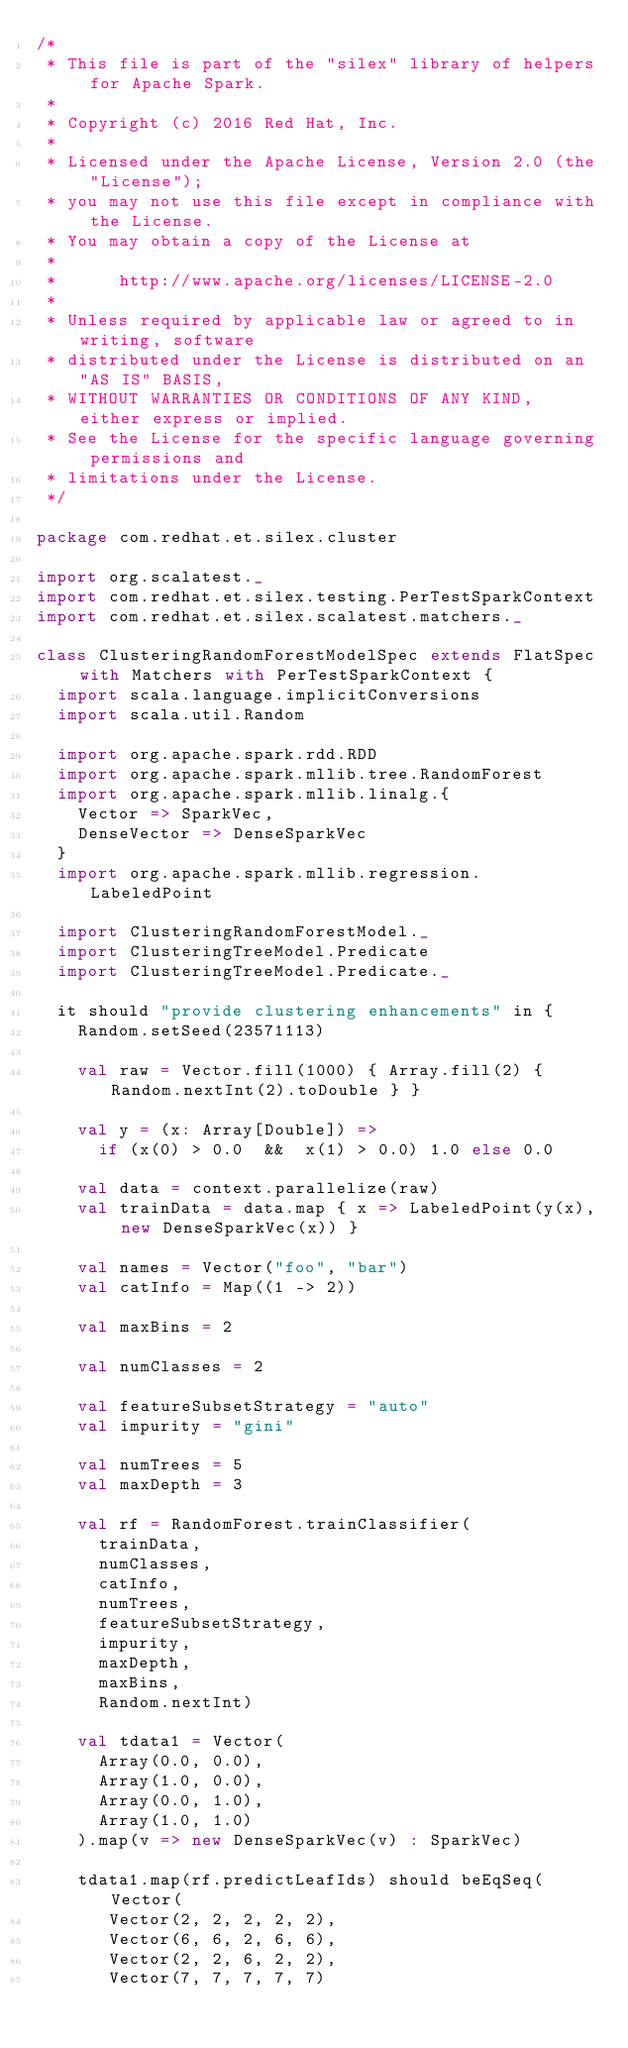Convert code to text. <code><loc_0><loc_0><loc_500><loc_500><_Scala_>/*
 * This file is part of the "silex" library of helpers for Apache Spark.
 *
 * Copyright (c) 2016 Red Hat, Inc.
 * 
 * Licensed under the Apache License, Version 2.0 (the "License");
 * you may not use this file except in compliance with the License.
 * You may obtain a copy of the License at
 * 
 *      http://www.apache.org/licenses/LICENSE-2.0
 * 
 * Unless required by applicable law or agreed to in writing, software
 * distributed under the License is distributed on an "AS IS" BASIS,
 * WITHOUT WARRANTIES OR CONDITIONS OF ANY KIND, either express or implied.
 * See the License for the specific language governing permissions and
 * limitations under the License.
 */

package com.redhat.et.silex.cluster

import org.scalatest._
import com.redhat.et.silex.testing.PerTestSparkContext
import com.redhat.et.silex.scalatest.matchers._

class ClusteringRandomForestModelSpec extends FlatSpec with Matchers with PerTestSparkContext {
  import scala.language.implicitConversions
  import scala.util.Random

  import org.apache.spark.rdd.RDD
  import org.apache.spark.mllib.tree.RandomForest
  import org.apache.spark.mllib.linalg.{
    Vector => SparkVec,
    DenseVector => DenseSparkVec
  }
  import org.apache.spark.mllib.regression.LabeledPoint

  import ClusteringRandomForestModel._
  import ClusteringTreeModel.Predicate
  import ClusteringTreeModel.Predicate._

  it should "provide clustering enhancements" in {
    Random.setSeed(23571113)

    val raw = Vector.fill(1000) { Array.fill(2) { Random.nextInt(2).toDouble } }

    val y = (x: Array[Double]) =>
      if (x(0) > 0.0  &&  x(1) > 0.0) 1.0 else 0.0

    val data = context.parallelize(raw)
    val trainData = data.map { x => LabeledPoint(y(x), new DenseSparkVec(x)) }

    val names = Vector("foo", "bar")
    val catInfo = Map((1 -> 2))

    val maxBins = 2

    val numClasses = 2

    val featureSubsetStrategy = "auto"
    val impurity = "gini"

    val numTrees = 5
    val maxDepth = 3

    val rf = RandomForest.trainClassifier(
      trainData,
      numClasses,
      catInfo,
      numTrees,
      featureSubsetStrategy,
      impurity,
      maxDepth,
      maxBins,
      Random.nextInt)

    val tdata1 = Vector(
      Array(0.0, 0.0),
      Array(1.0, 0.0),
      Array(0.0, 1.0),
      Array(1.0, 1.0)
    ).map(v => new DenseSparkVec(v) : SparkVec)

    tdata1.map(rf.predictLeafIds) should beEqSeq(Vector(
       Vector(2, 2, 2, 2, 2),
       Vector(6, 6, 2, 6, 6),
       Vector(2, 2, 6, 2, 2),
       Vector(7, 7, 7, 7, 7)</code> 